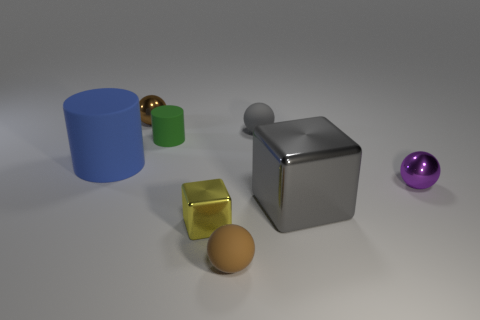Add 1 gray metallic cubes. How many objects exist? 9 Subtract all cylinders. How many objects are left? 6 Add 4 gray metal things. How many gray metal things exist? 5 Subtract 0 green cubes. How many objects are left? 8 Subtract all big red spheres. Subtract all small brown matte things. How many objects are left? 7 Add 6 big blue rubber cylinders. How many big blue rubber cylinders are left? 7 